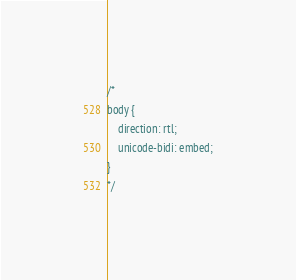<code> <loc_0><loc_0><loc_500><loc_500><_CSS_>
/*
body {
	direction: rtl;
	unicode-bidi: embed;
}
*/
</code> 